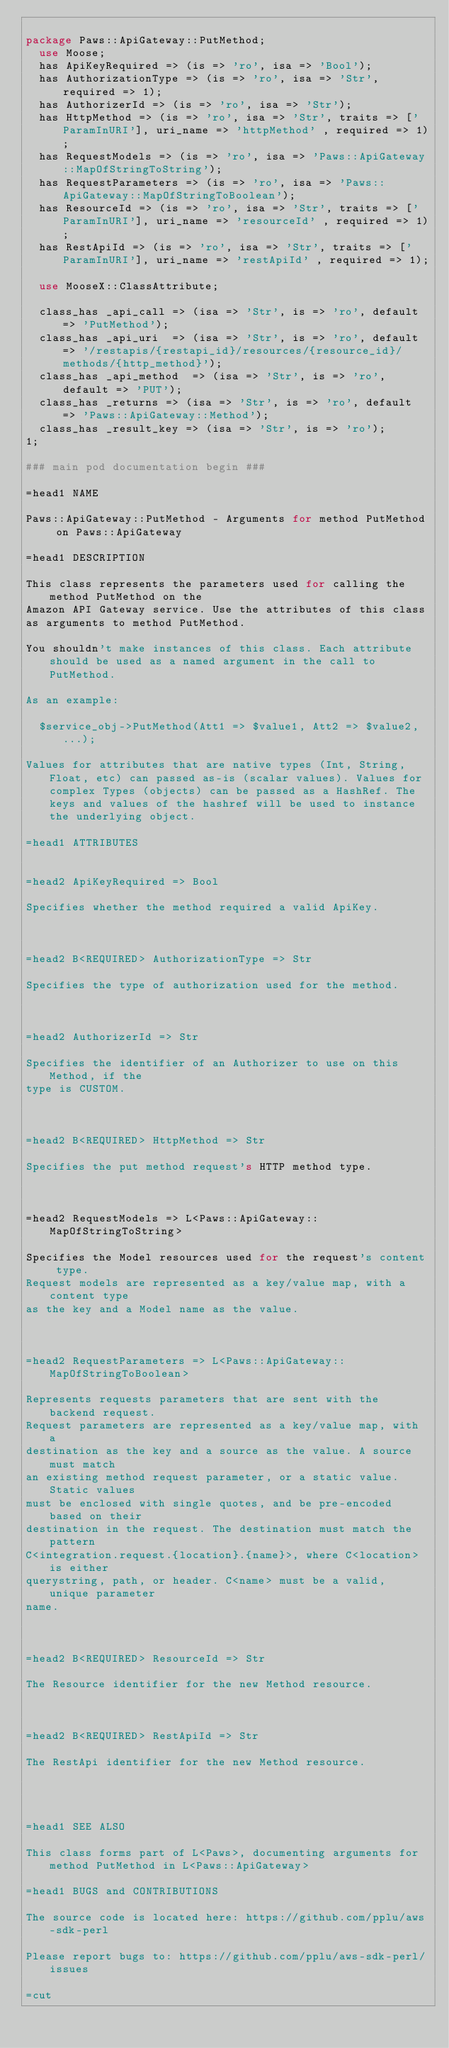<code> <loc_0><loc_0><loc_500><loc_500><_Perl_>
package Paws::ApiGateway::PutMethod;
  use Moose;
  has ApiKeyRequired => (is => 'ro', isa => 'Bool');
  has AuthorizationType => (is => 'ro', isa => 'Str', required => 1);
  has AuthorizerId => (is => 'ro', isa => 'Str');
  has HttpMethod => (is => 'ro', isa => 'Str', traits => ['ParamInURI'], uri_name => 'httpMethod' , required => 1);
  has RequestModels => (is => 'ro', isa => 'Paws::ApiGateway::MapOfStringToString');
  has RequestParameters => (is => 'ro', isa => 'Paws::ApiGateway::MapOfStringToBoolean');
  has ResourceId => (is => 'ro', isa => 'Str', traits => ['ParamInURI'], uri_name => 'resourceId' , required => 1);
  has RestApiId => (is => 'ro', isa => 'Str', traits => ['ParamInURI'], uri_name => 'restApiId' , required => 1);

  use MooseX::ClassAttribute;

  class_has _api_call => (isa => 'Str', is => 'ro', default => 'PutMethod');
  class_has _api_uri  => (isa => 'Str', is => 'ro', default => '/restapis/{restapi_id}/resources/{resource_id}/methods/{http_method}');
  class_has _api_method  => (isa => 'Str', is => 'ro', default => 'PUT');
  class_has _returns => (isa => 'Str', is => 'ro', default => 'Paws::ApiGateway::Method');
  class_has _result_key => (isa => 'Str', is => 'ro');
1;

### main pod documentation begin ###

=head1 NAME

Paws::ApiGateway::PutMethod - Arguments for method PutMethod on Paws::ApiGateway

=head1 DESCRIPTION

This class represents the parameters used for calling the method PutMethod on the 
Amazon API Gateway service. Use the attributes of this class
as arguments to method PutMethod.

You shouldn't make instances of this class. Each attribute should be used as a named argument in the call to PutMethod.

As an example:

  $service_obj->PutMethod(Att1 => $value1, Att2 => $value2, ...);

Values for attributes that are native types (Int, String, Float, etc) can passed as-is (scalar values). Values for complex Types (objects) can be passed as a HashRef. The keys and values of the hashref will be used to instance the underlying object.

=head1 ATTRIBUTES


=head2 ApiKeyRequired => Bool

Specifies whether the method required a valid ApiKey.



=head2 B<REQUIRED> AuthorizationType => Str

Specifies the type of authorization used for the method.



=head2 AuthorizerId => Str

Specifies the identifier of an Authorizer to use on this Method, if the
type is CUSTOM.



=head2 B<REQUIRED> HttpMethod => Str

Specifies the put method request's HTTP method type.



=head2 RequestModels => L<Paws::ApiGateway::MapOfStringToString>

Specifies the Model resources used for the request's content type.
Request models are represented as a key/value map, with a content type
as the key and a Model name as the value.



=head2 RequestParameters => L<Paws::ApiGateway::MapOfStringToBoolean>

Represents requests parameters that are sent with the backend request.
Request parameters are represented as a key/value map, with a
destination as the key and a source as the value. A source must match
an existing method request parameter, or a static value. Static values
must be enclosed with single quotes, and be pre-encoded based on their
destination in the request. The destination must match the pattern
C<integration.request.{location}.{name}>, where C<location> is either
querystring, path, or header. C<name> must be a valid, unique parameter
name.



=head2 B<REQUIRED> ResourceId => Str

The Resource identifier for the new Method resource.



=head2 B<REQUIRED> RestApiId => Str

The RestApi identifier for the new Method resource.




=head1 SEE ALSO

This class forms part of L<Paws>, documenting arguments for method PutMethod in L<Paws::ApiGateway>

=head1 BUGS and CONTRIBUTIONS

The source code is located here: https://github.com/pplu/aws-sdk-perl

Please report bugs to: https://github.com/pplu/aws-sdk-perl/issues

=cut

</code> 